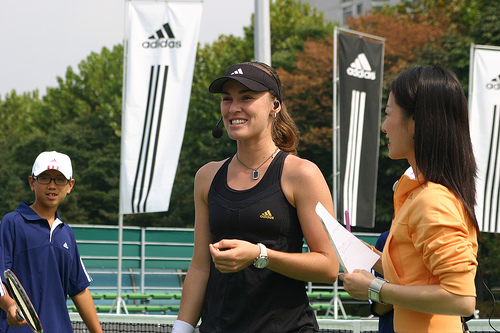<image>
Is there a hat on the woman? Yes. Looking at the image, I can see the hat is positioned on top of the woman, with the woman providing support. 